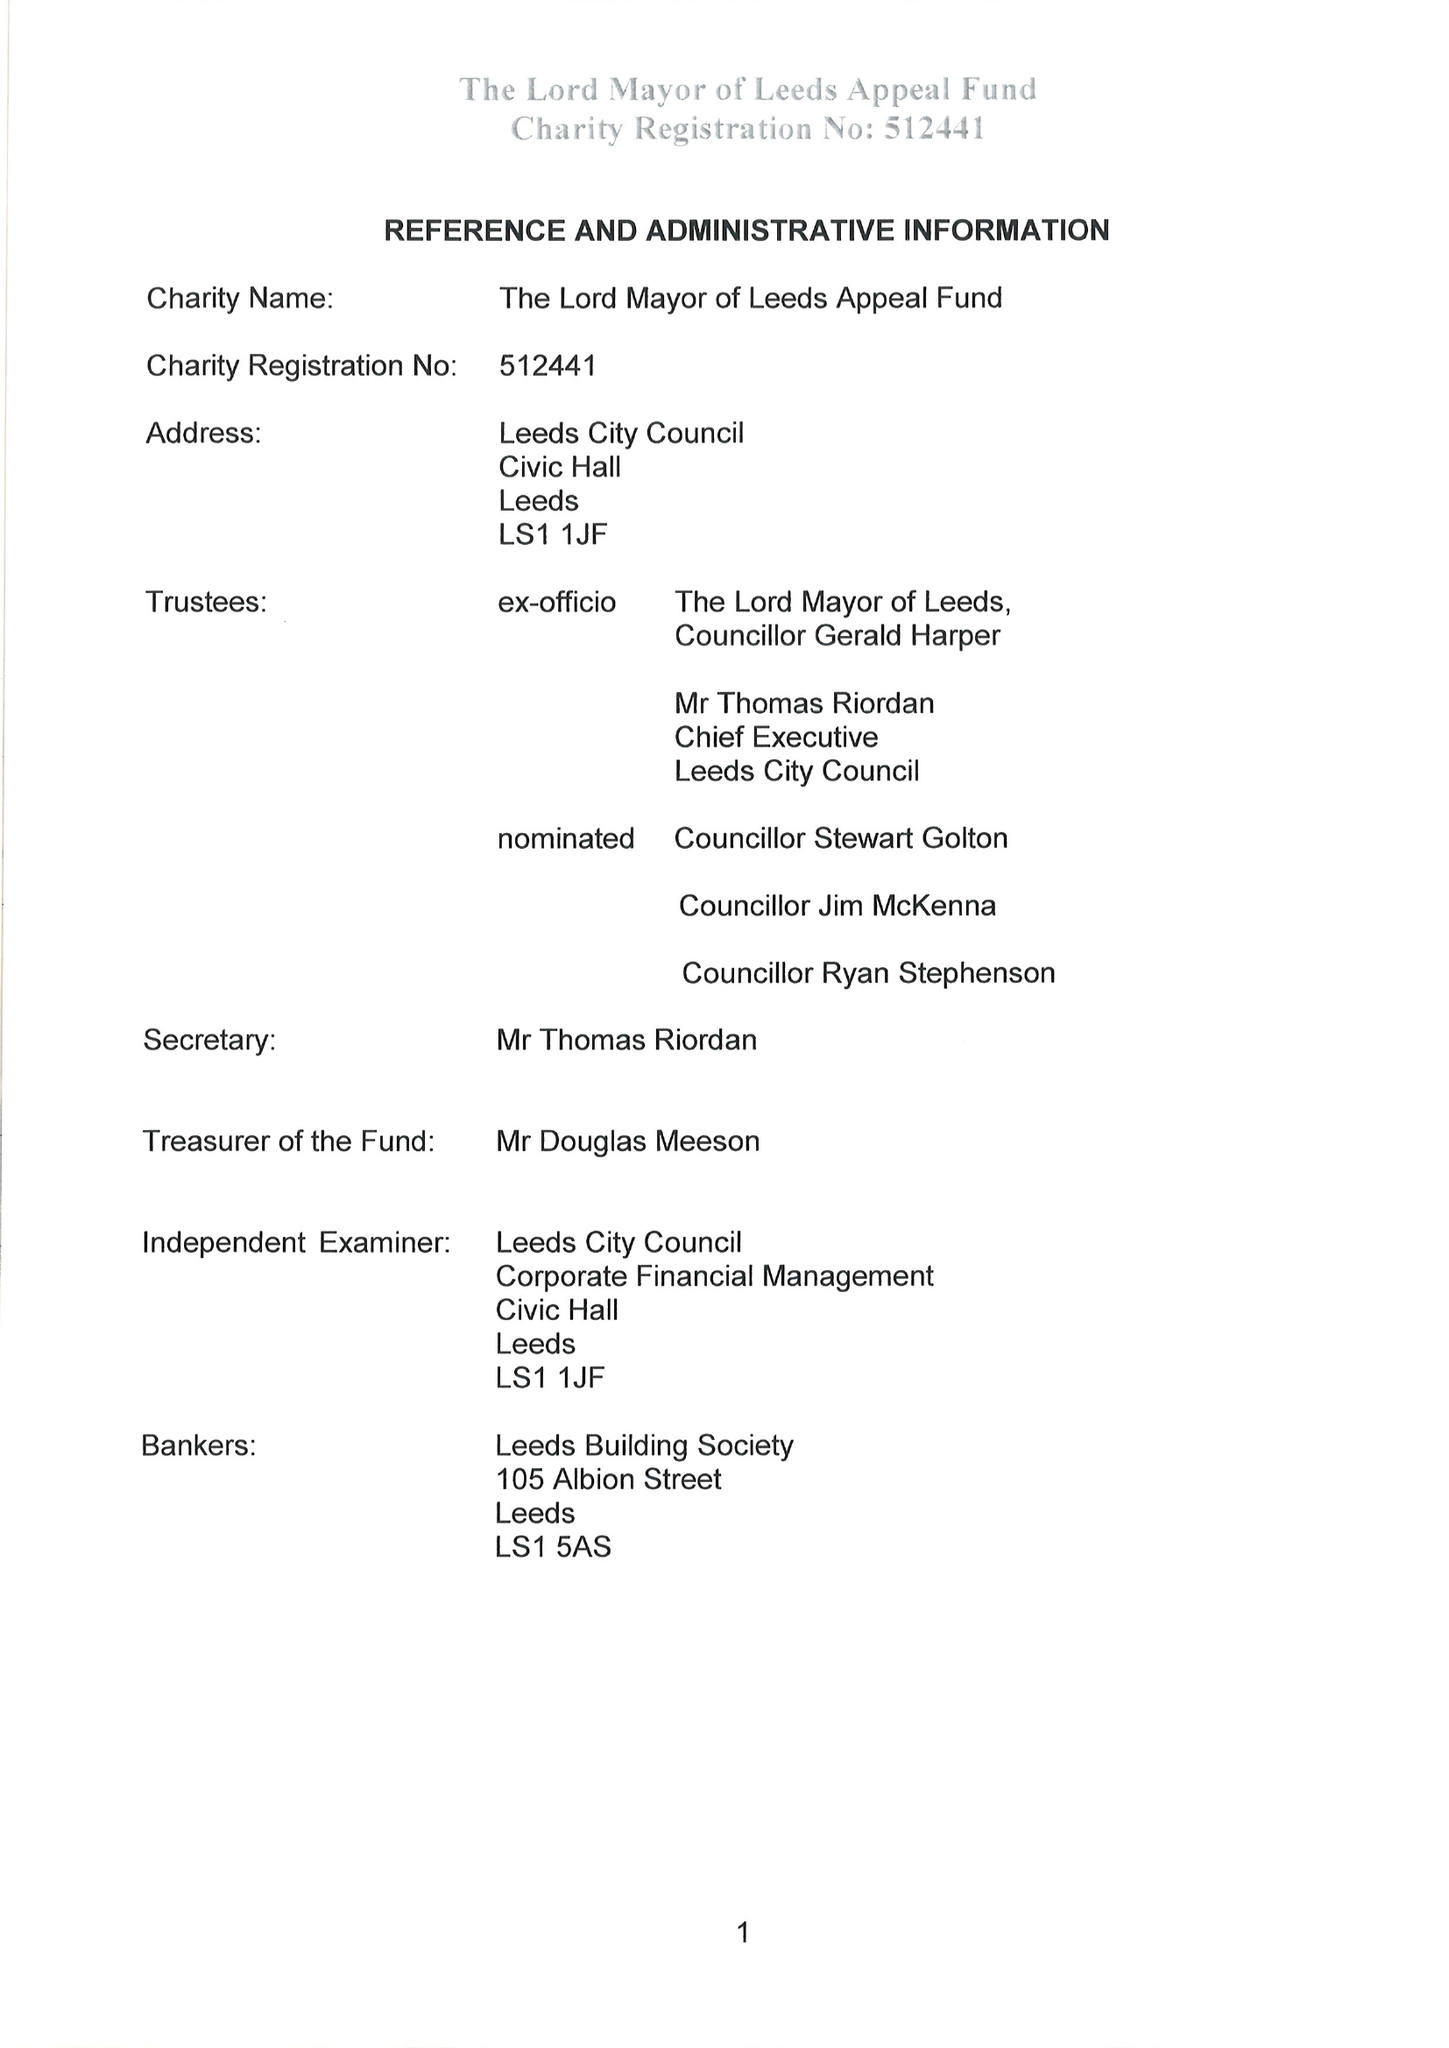What is the value for the address__postcode?
Answer the question using a single word or phrase. LS1 1JF 